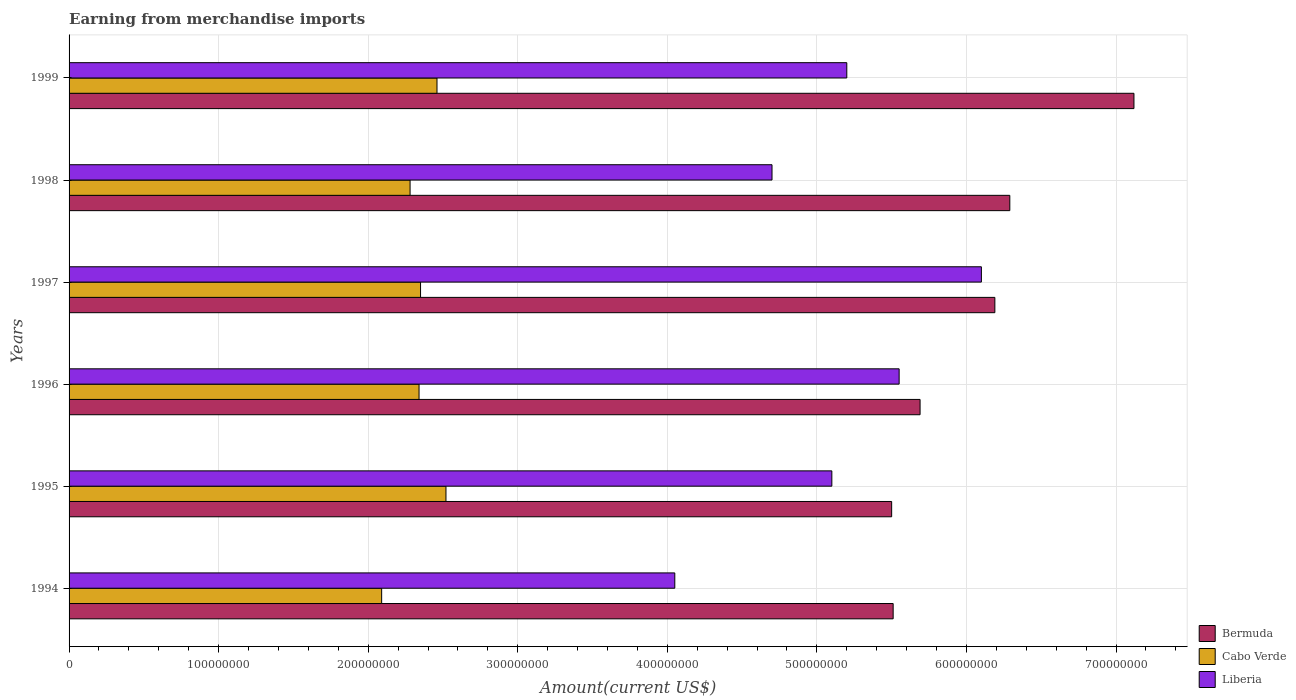How many groups of bars are there?
Ensure brevity in your answer.  6. Are the number of bars on each tick of the Y-axis equal?
Keep it short and to the point. Yes. How many bars are there on the 2nd tick from the top?
Keep it short and to the point. 3. What is the amount earned from merchandise imports in Liberia in 1996?
Your answer should be very brief. 5.55e+08. Across all years, what is the maximum amount earned from merchandise imports in Liberia?
Your response must be concise. 6.10e+08. Across all years, what is the minimum amount earned from merchandise imports in Cabo Verde?
Give a very brief answer. 2.09e+08. In which year was the amount earned from merchandise imports in Liberia maximum?
Provide a succinct answer. 1997. What is the total amount earned from merchandise imports in Liberia in the graph?
Provide a succinct answer. 3.07e+09. What is the difference between the amount earned from merchandise imports in Cabo Verde in 1996 and that in 1997?
Keep it short and to the point. -1.00e+06. What is the difference between the amount earned from merchandise imports in Liberia in 1994 and the amount earned from merchandise imports in Bermuda in 1998?
Provide a succinct answer. -2.24e+08. What is the average amount earned from merchandise imports in Bermuda per year?
Keep it short and to the point. 6.05e+08. In the year 1999, what is the difference between the amount earned from merchandise imports in Cabo Verde and amount earned from merchandise imports in Bermuda?
Your answer should be compact. -4.66e+08. In how many years, is the amount earned from merchandise imports in Bermuda greater than 80000000 US$?
Your response must be concise. 6. What is the ratio of the amount earned from merchandise imports in Liberia in 1997 to that in 1999?
Make the answer very short. 1.17. Is the difference between the amount earned from merchandise imports in Cabo Verde in 1994 and 1999 greater than the difference between the amount earned from merchandise imports in Bermuda in 1994 and 1999?
Offer a very short reply. Yes. What is the difference between the highest and the second highest amount earned from merchandise imports in Cabo Verde?
Offer a very short reply. 6.00e+06. What is the difference between the highest and the lowest amount earned from merchandise imports in Bermuda?
Provide a succinct answer. 1.62e+08. What does the 1st bar from the top in 1996 represents?
Provide a short and direct response. Liberia. What does the 3rd bar from the bottom in 1994 represents?
Your response must be concise. Liberia. Is it the case that in every year, the sum of the amount earned from merchandise imports in Liberia and amount earned from merchandise imports in Bermuda is greater than the amount earned from merchandise imports in Cabo Verde?
Ensure brevity in your answer.  Yes. How many bars are there?
Give a very brief answer. 18. What is the difference between two consecutive major ticks on the X-axis?
Your answer should be very brief. 1.00e+08. Does the graph contain any zero values?
Your answer should be very brief. No. What is the title of the graph?
Your answer should be compact. Earning from merchandise imports. Does "Somalia" appear as one of the legend labels in the graph?
Offer a terse response. No. What is the label or title of the X-axis?
Your answer should be very brief. Amount(current US$). What is the label or title of the Y-axis?
Give a very brief answer. Years. What is the Amount(current US$) of Bermuda in 1994?
Ensure brevity in your answer.  5.51e+08. What is the Amount(current US$) in Cabo Verde in 1994?
Your answer should be very brief. 2.09e+08. What is the Amount(current US$) of Liberia in 1994?
Offer a terse response. 4.05e+08. What is the Amount(current US$) of Bermuda in 1995?
Ensure brevity in your answer.  5.50e+08. What is the Amount(current US$) in Cabo Verde in 1995?
Offer a very short reply. 2.52e+08. What is the Amount(current US$) of Liberia in 1995?
Provide a short and direct response. 5.10e+08. What is the Amount(current US$) of Bermuda in 1996?
Ensure brevity in your answer.  5.69e+08. What is the Amount(current US$) in Cabo Verde in 1996?
Make the answer very short. 2.34e+08. What is the Amount(current US$) in Liberia in 1996?
Provide a short and direct response. 5.55e+08. What is the Amount(current US$) in Bermuda in 1997?
Offer a terse response. 6.19e+08. What is the Amount(current US$) of Cabo Verde in 1997?
Provide a succinct answer. 2.35e+08. What is the Amount(current US$) in Liberia in 1997?
Provide a succinct answer. 6.10e+08. What is the Amount(current US$) in Bermuda in 1998?
Offer a terse response. 6.29e+08. What is the Amount(current US$) in Cabo Verde in 1998?
Your response must be concise. 2.28e+08. What is the Amount(current US$) in Liberia in 1998?
Offer a terse response. 4.70e+08. What is the Amount(current US$) of Bermuda in 1999?
Give a very brief answer. 7.12e+08. What is the Amount(current US$) in Cabo Verde in 1999?
Keep it short and to the point. 2.46e+08. What is the Amount(current US$) of Liberia in 1999?
Keep it short and to the point. 5.20e+08. Across all years, what is the maximum Amount(current US$) in Bermuda?
Provide a succinct answer. 7.12e+08. Across all years, what is the maximum Amount(current US$) of Cabo Verde?
Offer a terse response. 2.52e+08. Across all years, what is the maximum Amount(current US$) of Liberia?
Your answer should be compact. 6.10e+08. Across all years, what is the minimum Amount(current US$) in Bermuda?
Your answer should be compact. 5.50e+08. Across all years, what is the minimum Amount(current US$) in Cabo Verde?
Your answer should be compact. 2.09e+08. Across all years, what is the minimum Amount(current US$) of Liberia?
Provide a succinct answer. 4.05e+08. What is the total Amount(current US$) of Bermuda in the graph?
Offer a terse response. 3.63e+09. What is the total Amount(current US$) of Cabo Verde in the graph?
Your answer should be very brief. 1.40e+09. What is the total Amount(current US$) in Liberia in the graph?
Provide a succinct answer. 3.07e+09. What is the difference between the Amount(current US$) of Cabo Verde in 1994 and that in 1995?
Your answer should be compact. -4.30e+07. What is the difference between the Amount(current US$) in Liberia in 1994 and that in 1995?
Ensure brevity in your answer.  -1.05e+08. What is the difference between the Amount(current US$) in Bermuda in 1994 and that in 1996?
Provide a short and direct response. -1.80e+07. What is the difference between the Amount(current US$) in Cabo Verde in 1994 and that in 1996?
Your response must be concise. -2.50e+07. What is the difference between the Amount(current US$) of Liberia in 1994 and that in 1996?
Give a very brief answer. -1.50e+08. What is the difference between the Amount(current US$) of Bermuda in 1994 and that in 1997?
Provide a short and direct response. -6.80e+07. What is the difference between the Amount(current US$) in Cabo Verde in 1994 and that in 1997?
Offer a very short reply. -2.60e+07. What is the difference between the Amount(current US$) in Liberia in 1994 and that in 1997?
Ensure brevity in your answer.  -2.05e+08. What is the difference between the Amount(current US$) of Bermuda in 1994 and that in 1998?
Ensure brevity in your answer.  -7.80e+07. What is the difference between the Amount(current US$) of Cabo Verde in 1994 and that in 1998?
Offer a terse response. -1.90e+07. What is the difference between the Amount(current US$) of Liberia in 1994 and that in 1998?
Provide a short and direct response. -6.50e+07. What is the difference between the Amount(current US$) in Bermuda in 1994 and that in 1999?
Keep it short and to the point. -1.61e+08. What is the difference between the Amount(current US$) in Cabo Verde in 1994 and that in 1999?
Your answer should be compact. -3.70e+07. What is the difference between the Amount(current US$) of Liberia in 1994 and that in 1999?
Offer a very short reply. -1.15e+08. What is the difference between the Amount(current US$) in Bermuda in 1995 and that in 1996?
Your response must be concise. -1.90e+07. What is the difference between the Amount(current US$) in Cabo Verde in 1995 and that in 1996?
Provide a short and direct response. 1.80e+07. What is the difference between the Amount(current US$) in Liberia in 1995 and that in 1996?
Provide a succinct answer. -4.50e+07. What is the difference between the Amount(current US$) in Bermuda in 1995 and that in 1997?
Offer a very short reply. -6.90e+07. What is the difference between the Amount(current US$) of Cabo Verde in 1995 and that in 1997?
Offer a terse response. 1.70e+07. What is the difference between the Amount(current US$) in Liberia in 1995 and that in 1997?
Offer a terse response. -1.00e+08. What is the difference between the Amount(current US$) of Bermuda in 1995 and that in 1998?
Keep it short and to the point. -7.90e+07. What is the difference between the Amount(current US$) in Cabo Verde in 1995 and that in 1998?
Your response must be concise. 2.40e+07. What is the difference between the Amount(current US$) of Liberia in 1995 and that in 1998?
Offer a terse response. 4.00e+07. What is the difference between the Amount(current US$) of Bermuda in 1995 and that in 1999?
Your answer should be compact. -1.62e+08. What is the difference between the Amount(current US$) of Liberia in 1995 and that in 1999?
Offer a terse response. -1.00e+07. What is the difference between the Amount(current US$) of Bermuda in 1996 and that in 1997?
Provide a succinct answer. -5.00e+07. What is the difference between the Amount(current US$) in Liberia in 1996 and that in 1997?
Give a very brief answer. -5.50e+07. What is the difference between the Amount(current US$) of Bermuda in 1996 and that in 1998?
Provide a short and direct response. -6.00e+07. What is the difference between the Amount(current US$) of Cabo Verde in 1996 and that in 1998?
Ensure brevity in your answer.  6.00e+06. What is the difference between the Amount(current US$) in Liberia in 1996 and that in 1998?
Your answer should be very brief. 8.50e+07. What is the difference between the Amount(current US$) in Bermuda in 1996 and that in 1999?
Your answer should be very brief. -1.43e+08. What is the difference between the Amount(current US$) of Cabo Verde in 1996 and that in 1999?
Make the answer very short. -1.20e+07. What is the difference between the Amount(current US$) of Liberia in 1996 and that in 1999?
Your answer should be compact. 3.50e+07. What is the difference between the Amount(current US$) of Bermuda in 1997 and that in 1998?
Offer a very short reply. -1.00e+07. What is the difference between the Amount(current US$) in Liberia in 1997 and that in 1998?
Offer a terse response. 1.40e+08. What is the difference between the Amount(current US$) in Bermuda in 1997 and that in 1999?
Offer a terse response. -9.30e+07. What is the difference between the Amount(current US$) in Cabo Verde in 1997 and that in 1999?
Make the answer very short. -1.10e+07. What is the difference between the Amount(current US$) in Liberia in 1997 and that in 1999?
Keep it short and to the point. 9.00e+07. What is the difference between the Amount(current US$) of Bermuda in 1998 and that in 1999?
Keep it short and to the point. -8.30e+07. What is the difference between the Amount(current US$) in Cabo Verde in 1998 and that in 1999?
Give a very brief answer. -1.80e+07. What is the difference between the Amount(current US$) of Liberia in 1998 and that in 1999?
Make the answer very short. -5.00e+07. What is the difference between the Amount(current US$) in Bermuda in 1994 and the Amount(current US$) in Cabo Verde in 1995?
Ensure brevity in your answer.  2.99e+08. What is the difference between the Amount(current US$) of Bermuda in 1994 and the Amount(current US$) of Liberia in 1995?
Provide a short and direct response. 4.10e+07. What is the difference between the Amount(current US$) in Cabo Verde in 1994 and the Amount(current US$) in Liberia in 1995?
Your response must be concise. -3.01e+08. What is the difference between the Amount(current US$) in Bermuda in 1994 and the Amount(current US$) in Cabo Verde in 1996?
Your response must be concise. 3.17e+08. What is the difference between the Amount(current US$) of Bermuda in 1994 and the Amount(current US$) of Liberia in 1996?
Provide a succinct answer. -4.00e+06. What is the difference between the Amount(current US$) of Cabo Verde in 1994 and the Amount(current US$) of Liberia in 1996?
Give a very brief answer. -3.46e+08. What is the difference between the Amount(current US$) in Bermuda in 1994 and the Amount(current US$) in Cabo Verde in 1997?
Provide a short and direct response. 3.16e+08. What is the difference between the Amount(current US$) of Bermuda in 1994 and the Amount(current US$) of Liberia in 1997?
Offer a very short reply. -5.90e+07. What is the difference between the Amount(current US$) in Cabo Verde in 1994 and the Amount(current US$) in Liberia in 1997?
Provide a short and direct response. -4.01e+08. What is the difference between the Amount(current US$) in Bermuda in 1994 and the Amount(current US$) in Cabo Verde in 1998?
Give a very brief answer. 3.23e+08. What is the difference between the Amount(current US$) of Bermuda in 1994 and the Amount(current US$) of Liberia in 1998?
Give a very brief answer. 8.10e+07. What is the difference between the Amount(current US$) in Cabo Verde in 1994 and the Amount(current US$) in Liberia in 1998?
Give a very brief answer. -2.61e+08. What is the difference between the Amount(current US$) in Bermuda in 1994 and the Amount(current US$) in Cabo Verde in 1999?
Make the answer very short. 3.05e+08. What is the difference between the Amount(current US$) in Bermuda in 1994 and the Amount(current US$) in Liberia in 1999?
Keep it short and to the point. 3.10e+07. What is the difference between the Amount(current US$) of Cabo Verde in 1994 and the Amount(current US$) of Liberia in 1999?
Give a very brief answer. -3.11e+08. What is the difference between the Amount(current US$) of Bermuda in 1995 and the Amount(current US$) of Cabo Verde in 1996?
Keep it short and to the point. 3.16e+08. What is the difference between the Amount(current US$) of Bermuda in 1995 and the Amount(current US$) of Liberia in 1996?
Keep it short and to the point. -5.00e+06. What is the difference between the Amount(current US$) in Cabo Verde in 1995 and the Amount(current US$) in Liberia in 1996?
Your answer should be very brief. -3.03e+08. What is the difference between the Amount(current US$) of Bermuda in 1995 and the Amount(current US$) of Cabo Verde in 1997?
Keep it short and to the point. 3.15e+08. What is the difference between the Amount(current US$) in Bermuda in 1995 and the Amount(current US$) in Liberia in 1997?
Make the answer very short. -6.00e+07. What is the difference between the Amount(current US$) of Cabo Verde in 1995 and the Amount(current US$) of Liberia in 1997?
Offer a terse response. -3.58e+08. What is the difference between the Amount(current US$) of Bermuda in 1995 and the Amount(current US$) of Cabo Verde in 1998?
Make the answer very short. 3.22e+08. What is the difference between the Amount(current US$) of Bermuda in 1995 and the Amount(current US$) of Liberia in 1998?
Ensure brevity in your answer.  8.00e+07. What is the difference between the Amount(current US$) of Cabo Verde in 1995 and the Amount(current US$) of Liberia in 1998?
Your response must be concise. -2.18e+08. What is the difference between the Amount(current US$) in Bermuda in 1995 and the Amount(current US$) in Cabo Verde in 1999?
Your answer should be very brief. 3.04e+08. What is the difference between the Amount(current US$) in Bermuda in 1995 and the Amount(current US$) in Liberia in 1999?
Ensure brevity in your answer.  3.00e+07. What is the difference between the Amount(current US$) in Cabo Verde in 1995 and the Amount(current US$) in Liberia in 1999?
Keep it short and to the point. -2.68e+08. What is the difference between the Amount(current US$) of Bermuda in 1996 and the Amount(current US$) of Cabo Verde in 1997?
Give a very brief answer. 3.34e+08. What is the difference between the Amount(current US$) of Bermuda in 1996 and the Amount(current US$) of Liberia in 1997?
Provide a short and direct response. -4.10e+07. What is the difference between the Amount(current US$) in Cabo Verde in 1996 and the Amount(current US$) in Liberia in 1997?
Your response must be concise. -3.76e+08. What is the difference between the Amount(current US$) in Bermuda in 1996 and the Amount(current US$) in Cabo Verde in 1998?
Provide a succinct answer. 3.41e+08. What is the difference between the Amount(current US$) in Bermuda in 1996 and the Amount(current US$) in Liberia in 1998?
Your answer should be compact. 9.90e+07. What is the difference between the Amount(current US$) in Cabo Verde in 1996 and the Amount(current US$) in Liberia in 1998?
Offer a terse response. -2.36e+08. What is the difference between the Amount(current US$) of Bermuda in 1996 and the Amount(current US$) of Cabo Verde in 1999?
Your response must be concise. 3.23e+08. What is the difference between the Amount(current US$) in Bermuda in 1996 and the Amount(current US$) in Liberia in 1999?
Your answer should be very brief. 4.90e+07. What is the difference between the Amount(current US$) of Cabo Verde in 1996 and the Amount(current US$) of Liberia in 1999?
Provide a succinct answer. -2.86e+08. What is the difference between the Amount(current US$) in Bermuda in 1997 and the Amount(current US$) in Cabo Verde in 1998?
Keep it short and to the point. 3.91e+08. What is the difference between the Amount(current US$) in Bermuda in 1997 and the Amount(current US$) in Liberia in 1998?
Keep it short and to the point. 1.49e+08. What is the difference between the Amount(current US$) in Cabo Verde in 1997 and the Amount(current US$) in Liberia in 1998?
Offer a very short reply. -2.35e+08. What is the difference between the Amount(current US$) of Bermuda in 1997 and the Amount(current US$) of Cabo Verde in 1999?
Give a very brief answer. 3.73e+08. What is the difference between the Amount(current US$) in Bermuda in 1997 and the Amount(current US$) in Liberia in 1999?
Your answer should be very brief. 9.90e+07. What is the difference between the Amount(current US$) in Cabo Verde in 1997 and the Amount(current US$) in Liberia in 1999?
Your response must be concise. -2.85e+08. What is the difference between the Amount(current US$) of Bermuda in 1998 and the Amount(current US$) of Cabo Verde in 1999?
Keep it short and to the point. 3.83e+08. What is the difference between the Amount(current US$) of Bermuda in 1998 and the Amount(current US$) of Liberia in 1999?
Your response must be concise. 1.09e+08. What is the difference between the Amount(current US$) in Cabo Verde in 1998 and the Amount(current US$) in Liberia in 1999?
Offer a terse response. -2.92e+08. What is the average Amount(current US$) in Bermuda per year?
Make the answer very short. 6.05e+08. What is the average Amount(current US$) in Cabo Verde per year?
Your response must be concise. 2.34e+08. What is the average Amount(current US$) in Liberia per year?
Offer a very short reply. 5.12e+08. In the year 1994, what is the difference between the Amount(current US$) of Bermuda and Amount(current US$) of Cabo Verde?
Offer a terse response. 3.42e+08. In the year 1994, what is the difference between the Amount(current US$) of Bermuda and Amount(current US$) of Liberia?
Offer a terse response. 1.46e+08. In the year 1994, what is the difference between the Amount(current US$) in Cabo Verde and Amount(current US$) in Liberia?
Make the answer very short. -1.96e+08. In the year 1995, what is the difference between the Amount(current US$) of Bermuda and Amount(current US$) of Cabo Verde?
Your response must be concise. 2.98e+08. In the year 1995, what is the difference between the Amount(current US$) of Bermuda and Amount(current US$) of Liberia?
Your answer should be very brief. 4.00e+07. In the year 1995, what is the difference between the Amount(current US$) in Cabo Verde and Amount(current US$) in Liberia?
Provide a succinct answer. -2.58e+08. In the year 1996, what is the difference between the Amount(current US$) of Bermuda and Amount(current US$) of Cabo Verde?
Give a very brief answer. 3.35e+08. In the year 1996, what is the difference between the Amount(current US$) in Bermuda and Amount(current US$) in Liberia?
Keep it short and to the point. 1.40e+07. In the year 1996, what is the difference between the Amount(current US$) of Cabo Verde and Amount(current US$) of Liberia?
Provide a short and direct response. -3.21e+08. In the year 1997, what is the difference between the Amount(current US$) of Bermuda and Amount(current US$) of Cabo Verde?
Keep it short and to the point. 3.84e+08. In the year 1997, what is the difference between the Amount(current US$) in Bermuda and Amount(current US$) in Liberia?
Give a very brief answer. 9.00e+06. In the year 1997, what is the difference between the Amount(current US$) of Cabo Verde and Amount(current US$) of Liberia?
Your response must be concise. -3.75e+08. In the year 1998, what is the difference between the Amount(current US$) in Bermuda and Amount(current US$) in Cabo Verde?
Offer a terse response. 4.01e+08. In the year 1998, what is the difference between the Amount(current US$) of Bermuda and Amount(current US$) of Liberia?
Ensure brevity in your answer.  1.59e+08. In the year 1998, what is the difference between the Amount(current US$) in Cabo Verde and Amount(current US$) in Liberia?
Provide a succinct answer. -2.42e+08. In the year 1999, what is the difference between the Amount(current US$) of Bermuda and Amount(current US$) of Cabo Verde?
Make the answer very short. 4.66e+08. In the year 1999, what is the difference between the Amount(current US$) of Bermuda and Amount(current US$) of Liberia?
Provide a succinct answer. 1.92e+08. In the year 1999, what is the difference between the Amount(current US$) of Cabo Verde and Amount(current US$) of Liberia?
Your response must be concise. -2.74e+08. What is the ratio of the Amount(current US$) in Bermuda in 1994 to that in 1995?
Your answer should be very brief. 1. What is the ratio of the Amount(current US$) in Cabo Verde in 1994 to that in 1995?
Ensure brevity in your answer.  0.83. What is the ratio of the Amount(current US$) in Liberia in 1994 to that in 1995?
Make the answer very short. 0.79. What is the ratio of the Amount(current US$) of Bermuda in 1994 to that in 1996?
Your answer should be very brief. 0.97. What is the ratio of the Amount(current US$) of Cabo Verde in 1994 to that in 1996?
Provide a succinct answer. 0.89. What is the ratio of the Amount(current US$) of Liberia in 1994 to that in 1996?
Your answer should be very brief. 0.73. What is the ratio of the Amount(current US$) of Bermuda in 1994 to that in 1997?
Offer a very short reply. 0.89. What is the ratio of the Amount(current US$) of Cabo Verde in 1994 to that in 1997?
Your answer should be compact. 0.89. What is the ratio of the Amount(current US$) of Liberia in 1994 to that in 1997?
Your answer should be very brief. 0.66. What is the ratio of the Amount(current US$) of Bermuda in 1994 to that in 1998?
Your response must be concise. 0.88. What is the ratio of the Amount(current US$) in Cabo Verde in 1994 to that in 1998?
Your response must be concise. 0.92. What is the ratio of the Amount(current US$) in Liberia in 1994 to that in 1998?
Offer a terse response. 0.86. What is the ratio of the Amount(current US$) of Bermuda in 1994 to that in 1999?
Give a very brief answer. 0.77. What is the ratio of the Amount(current US$) of Cabo Verde in 1994 to that in 1999?
Make the answer very short. 0.85. What is the ratio of the Amount(current US$) of Liberia in 1994 to that in 1999?
Give a very brief answer. 0.78. What is the ratio of the Amount(current US$) in Bermuda in 1995 to that in 1996?
Make the answer very short. 0.97. What is the ratio of the Amount(current US$) of Liberia in 1995 to that in 1996?
Ensure brevity in your answer.  0.92. What is the ratio of the Amount(current US$) of Bermuda in 1995 to that in 1997?
Your answer should be compact. 0.89. What is the ratio of the Amount(current US$) of Cabo Verde in 1995 to that in 1997?
Offer a very short reply. 1.07. What is the ratio of the Amount(current US$) of Liberia in 1995 to that in 1997?
Make the answer very short. 0.84. What is the ratio of the Amount(current US$) in Bermuda in 1995 to that in 1998?
Ensure brevity in your answer.  0.87. What is the ratio of the Amount(current US$) of Cabo Verde in 1995 to that in 1998?
Offer a terse response. 1.11. What is the ratio of the Amount(current US$) of Liberia in 1995 to that in 1998?
Provide a short and direct response. 1.09. What is the ratio of the Amount(current US$) of Bermuda in 1995 to that in 1999?
Offer a terse response. 0.77. What is the ratio of the Amount(current US$) of Cabo Verde in 1995 to that in 1999?
Ensure brevity in your answer.  1.02. What is the ratio of the Amount(current US$) of Liberia in 1995 to that in 1999?
Provide a succinct answer. 0.98. What is the ratio of the Amount(current US$) in Bermuda in 1996 to that in 1997?
Your response must be concise. 0.92. What is the ratio of the Amount(current US$) in Cabo Verde in 1996 to that in 1997?
Offer a terse response. 1. What is the ratio of the Amount(current US$) in Liberia in 1996 to that in 1997?
Make the answer very short. 0.91. What is the ratio of the Amount(current US$) of Bermuda in 1996 to that in 1998?
Make the answer very short. 0.9. What is the ratio of the Amount(current US$) of Cabo Verde in 1996 to that in 1998?
Your answer should be very brief. 1.03. What is the ratio of the Amount(current US$) of Liberia in 1996 to that in 1998?
Provide a short and direct response. 1.18. What is the ratio of the Amount(current US$) in Bermuda in 1996 to that in 1999?
Provide a succinct answer. 0.8. What is the ratio of the Amount(current US$) in Cabo Verde in 1996 to that in 1999?
Ensure brevity in your answer.  0.95. What is the ratio of the Amount(current US$) of Liberia in 1996 to that in 1999?
Offer a very short reply. 1.07. What is the ratio of the Amount(current US$) of Bermuda in 1997 to that in 1998?
Your response must be concise. 0.98. What is the ratio of the Amount(current US$) in Cabo Verde in 1997 to that in 1998?
Give a very brief answer. 1.03. What is the ratio of the Amount(current US$) in Liberia in 1997 to that in 1998?
Provide a succinct answer. 1.3. What is the ratio of the Amount(current US$) in Bermuda in 1997 to that in 1999?
Your answer should be very brief. 0.87. What is the ratio of the Amount(current US$) of Cabo Verde in 1997 to that in 1999?
Provide a short and direct response. 0.96. What is the ratio of the Amount(current US$) of Liberia in 1997 to that in 1999?
Provide a succinct answer. 1.17. What is the ratio of the Amount(current US$) in Bermuda in 1998 to that in 1999?
Give a very brief answer. 0.88. What is the ratio of the Amount(current US$) of Cabo Verde in 1998 to that in 1999?
Give a very brief answer. 0.93. What is the ratio of the Amount(current US$) in Liberia in 1998 to that in 1999?
Your answer should be compact. 0.9. What is the difference between the highest and the second highest Amount(current US$) in Bermuda?
Give a very brief answer. 8.30e+07. What is the difference between the highest and the second highest Amount(current US$) in Cabo Verde?
Your answer should be compact. 6.00e+06. What is the difference between the highest and the second highest Amount(current US$) in Liberia?
Offer a very short reply. 5.50e+07. What is the difference between the highest and the lowest Amount(current US$) of Bermuda?
Provide a short and direct response. 1.62e+08. What is the difference between the highest and the lowest Amount(current US$) in Cabo Verde?
Keep it short and to the point. 4.30e+07. What is the difference between the highest and the lowest Amount(current US$) of Liberia?
Your answer should be very brief. 2.05e+08. 